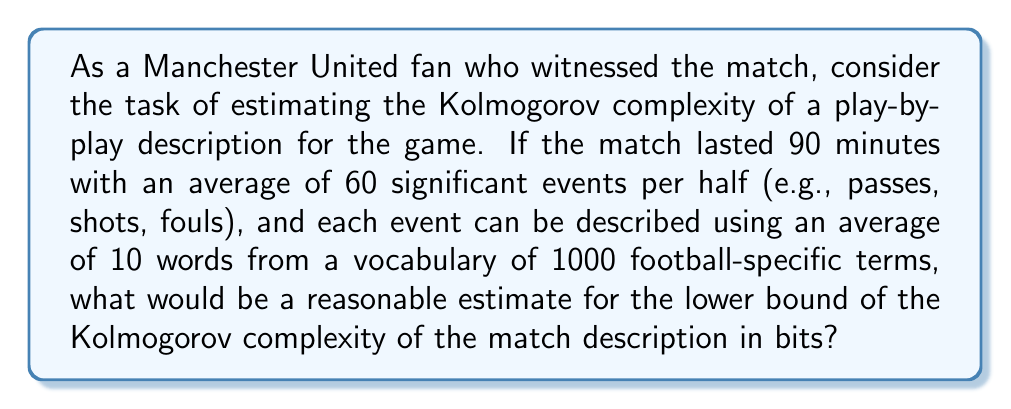Provide a solution to this math problem. To estimate the lower bound of the Kolmogorov complexity for the match description, we need to consider the minimum amount of information required to represent the play-by-play account. Let's break this down step-by-step:

1. Number of events:
   - 90-minute match
   - 60 significant events per half
   - Total events = $60 \times 2 = 120$ events

2. Description of each event:
   - Average of 10 words per event
   - Vocabulary of 1000 football-specific terms

3. Information content per word:
   - With a vocabulary of 1000 terms, we need $\log_2(1000) \approx 10$ bits to represent each word

4. Information content per event:
   - $10$ words/event $\times 10$ bits/word $= 100$ bits/event

5. Total information content:
   - $120$ events $\times 100$ bits/event $= 12,000$ bits

6. Additional structural information:
   - We need some extra bits to represent the structure of the description, such as the order of events, time stamps, etc.
   - Let's estimate this as an additional 20% of the total information content
   - Additional bits = $12,000 \times 0.20 = 2,400$ bits

7. Lower bound estimate:
   - Total bits = Event description + Structural information
   - $12,000 + 2,400 = 14,400$ bits

Therefore, a reasonable estimate for the lower bound of the Kolmogorov complexity of the match description would be approximately 14,400 bits.

Note that this is a lower bound estimate because:
1. The actual description might require more words or a larger vocabulary.
2. There might be more complex structures or patterns in the play-by-play that require additional information to describe.
3. The Kolmogorov complexity represents the length of the shortest possible program that can generate the description, which might be more compact than our estimate.
Answer: A reasonable estimate for the lower bound of the Kolmogorov complexity of the match description is approximately 14,400 bits. 